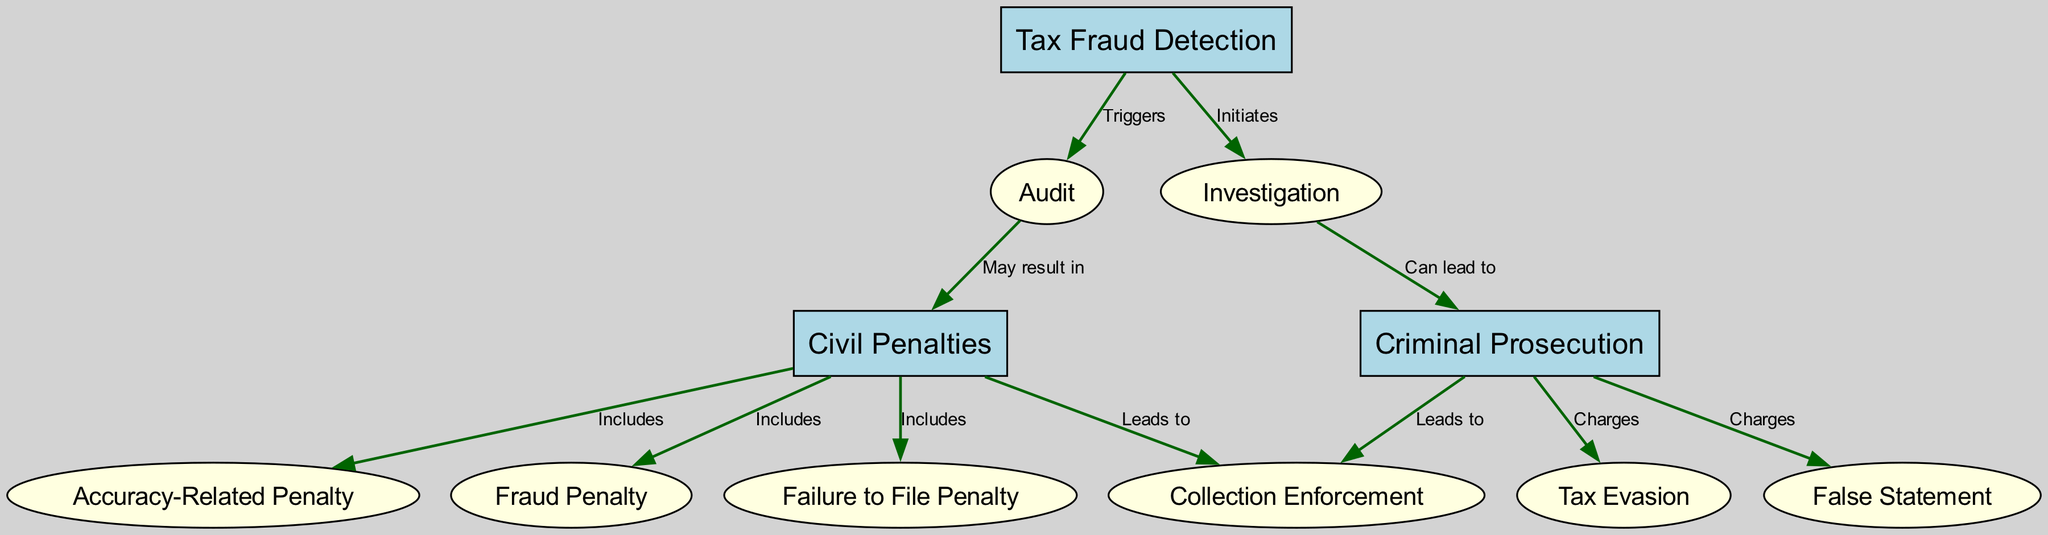What are the three main types of penalties shown in the diagram? The diagram lists three main types of penalties under "Civil Penalties": Accuracy-Related Penalty, Fraud Penalty, and Failure to File Penalty. These are the primary categories of civil consequences arising from tax fraud.
Answer: Accuracy-Related Penalty, Fraud Penalty, Failure to File Penalty How many nodes are there in the diagram? The diagram contains a total of 11 nodes, including Tax Fraud Detection, Civil Penalties, Criminal Prosecution, and others listed in the nodes section of the data.
Answer: 11 What action can lead to Criminal Prosecution? The "Investigation" node is connected to "Criminal Prosecution" with the label "Can lead to." This indicates that when an investigation occurs, it can result in criminal charges being pursued.
Answer: Investigation Which penalties are included under Civil Penalties? Civil Penalties include Accuracy-Related Penalty, Fraud Penalty, and Failure to File Penalty, as indicated by the direct connections from "Civil Penalties" to these penalty types within the diagram.
Answer: Accuracy-Related Penalty, Fraud Penalty, Failure to File Penalty What triggers an Audit according to the diagram? The diagram indicates that "Tax Fraud Detection" triggers an "Audit." This relationship is established with the edge labeled "Triggers," showing that fraud detection processes can initiate an audit.
Answer: Tax Fraud Detection Which two nodes lead to Collection Enforcement? Both "Civil Penalties" and "Criminal Prosecution" lead to "Collection Enforcement," indicating that penalties imposed can result in collection actions. This is evident from the edges labeled "Leads to."
Answer: Civil Penalties, Criminal Prosecution How many types of fraud are charged in Criminal Prosecution? The diagram displays two types of charges under "Criminal Prosecution": "Tax Evasion" and "False Statement," suggesting that both are potential criminal charges stemming from prosecution.
Answer: 2 What happens after an Audit according to the diagram? An Audit may result in "Civil Penalties," indicating that following an audit, various civil penalties can be imposed based on the audit findings.
Answer: Civil Penalties Which node represents the starting point for the whole process shown in the diagram? "Tax Fraud Detection" is the starting point for the entire process, triggering both Audit and Investigation, which lead to further actions and penalties as shown in the directed graph.
Answer: Tax Fraud Detection 